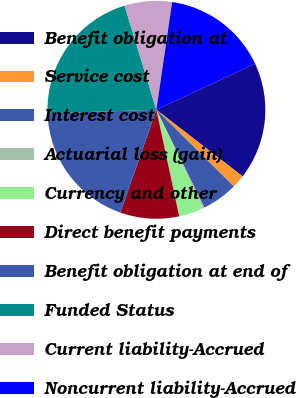Convert chart. <chart><loc_0><loc_0><loc_500><loc_500><pie_chart><fcel>Benefit obligation at<fcel>Service cost<fcel>Interest cost<fcel>Actuarial loss (gain)<fcel>Currency and other<fcel>Direct benefit payments<fcel>Benefit obligation at end of<fcel>Funded Status<fcel>Current liability-Accrued<fcel>Noncurrent liability-Accrued<nl><fcel>17.42%<fcel>1.95%<fcel>5.33%<fcel>0.26%<fcel>3.64%<fcel>8.72%<fcel>19.11%<fcel>20.8%<fcel>7.03%<fcel>15.73%<nl></chart> 